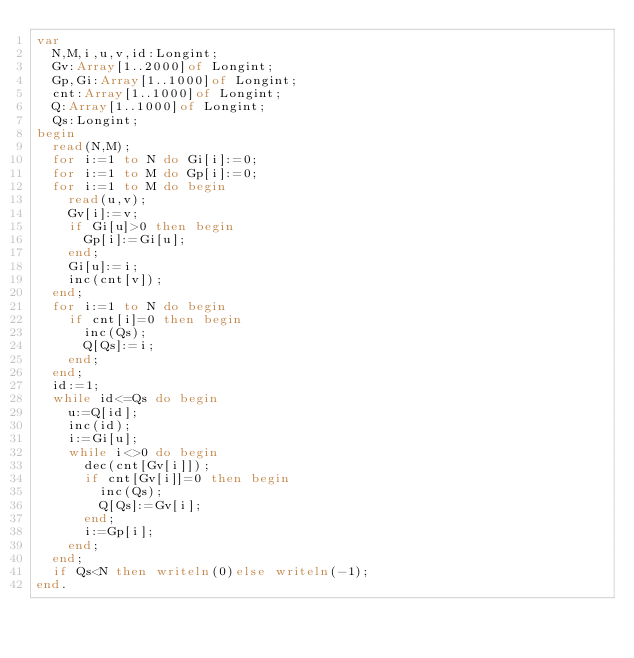<code> <loc_0><loc_0><loc_500><loc_500><_Pascal_>var
	N,M,i,u,v,id:Longint;
	Gv:Array[1..2000]of Longint;
	Gp,Gi:Array[1..1000]of Longint;
	cnt:Array[1..1000]of Longint;
	Q:Array[1..1000]of Longint;
	Qs:Longint;
begin
	read(N,M);
	for i:=1 to N do Gi[i]:=0;
	for i:=1 to M do Gp[i]:=0;
	for i:=1 to M do begin
		read(u,v);
		Gv[i]:=v;
		if Gi[u]>0 then begin
			Gp[i]:=Gi[u];
		end;
		Gi[u]:=i;
		inc(cnt[v]);
	end;
	for i:=1 to N do begin
		if cnt[i]=0 then begin
			inc(Qs);
			Q[Qs]:=i;
		end;
	end;
	id:=1;
	while id<=Qs do begin
		u:=Q[id];
		inc(id);
		i:=Gi[u];
		while i<>0 do begin
			dec(cnt[Gv[i]]);
			if cnt[Gv[i]]=0 then begin
				inc(Qs);
				Q[Qs]:=Gv[i];
			end;
			i:=Gp[i];
		end;
	end;
	if Qs<N then writeln(0)else writeln(-1);
end.
</code> 